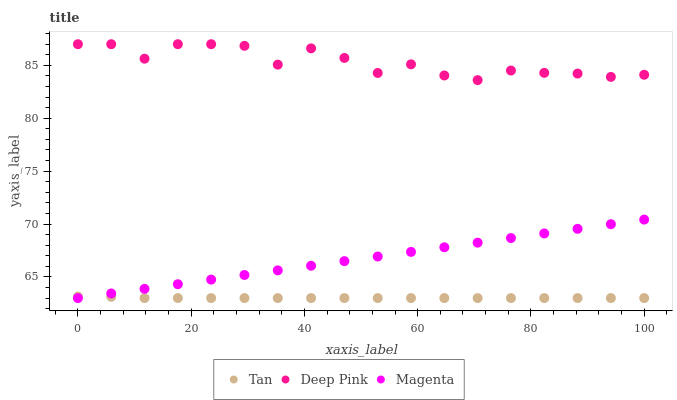Does Tan have the minimum area under the curve?
Answer yes or no. Yes. Does Deep Pink have the maximum area under the curve?
Answer yes or no. Yes. Does Magenta have the minimum area under the curve?
Answer yes or no. No. Does Magenta have the maximum area under the curve?
Answer yes or no. No. Is Magenta the smoothest?
Answer yes or no. Yes. Is Deep Pink the roughest?
Answer yes or no. Yes. Is Deep Pink the smoothest?
Answer yes or no. No. Is Magenta the roughest?
Answer yes or no. No. Does Tan have the lowest value?
Answer yes or no. Yes. Does Deep Pink have the lowest value?
Answer yes or no. No. Does Deep Pink have the highest value?
Answer yes or no. Yes. Does Magenta have the highest value?
Answer yes or no. No. Is Magenta less than Deep Pink?
Answer yes or no. Yes. Is Deep Pink greater than Tan?
Answer yes or no. Yes. Does Magenta intersect Tan?
Answer yes or no. Yes. Is Magenta less than Tan?
Answer yes or no. No. Is Magenta greater than Tan?
Answer yes or no. No. Does Magenta intersect Deep Pink?
Answer yes or no. No. 